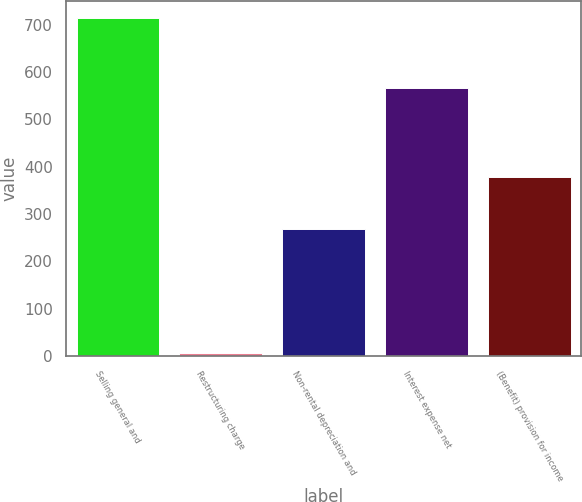Convert chart. <chart><loc_0><loc_0><loc_500><loc_500><bar_chart><fcel>Selling general and<fcel>Restructuring charge<fcel>Non-rental depreciation and<fcel>Interest expense net<fcel>(Benefit) provision for income<nl><fcel>714<fcel>6<fcel>268<fcel>567<fcel>378<nl></chart> 